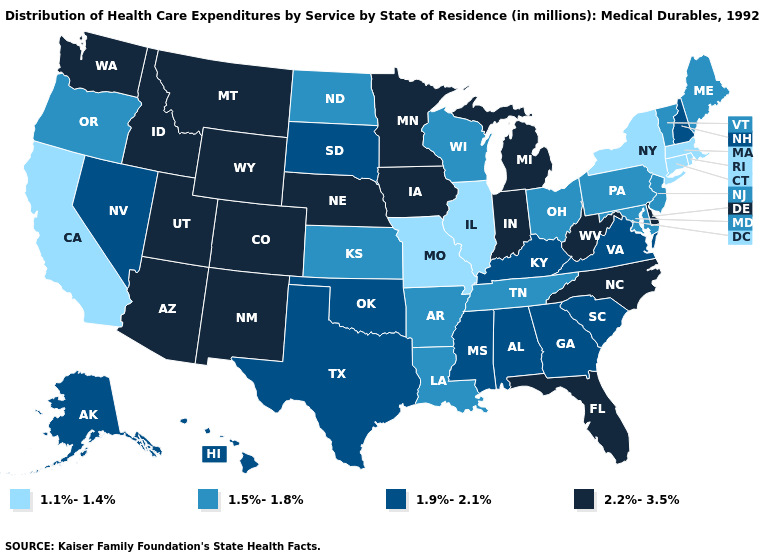Does the first symbol in the legend represent the smallest category?
Give a very brief answer. Yes. What is the lowest value in states that border South Carolina?
Be succinct. 1.9%-2.1%. Does Illinois have the lowest value in the USA?
Give a very brief answer. Yes. Name the states that have a value in the range 2.2%-3.5%?
Concise answer only. Arizona, Colorado, Delaware, Florida, Idaho, Indiana, Iowa, Michigan, Minnesota, Montana, Nebraska, New Mexico, North Carolina, Utah, Washington, West Virginia, Wyoming. What is the value of California?
Concise answer only. 1.1%-1.4%. Name the states that have a value in the range 1.5%-1.8%?
Write a very short answer. Arkansas, Kansas, Louisiana, Maine, Maryland, New Jersey, North Dakota, Ohio, Oregon, Pennsylvania, Tennessee, Vermont, Wisconsin. What is the value of Washington?
Short answer required. 2.2%-3.5%. What is the value of Arizona?
Keep it brief. 2.2%-3.5%. Name the states that have a value in the range 1.5%-1.8%?
Keep it brief. Arkansas, Kansas, Louisiana, Maine, Maryland, New Jersey, North Dakota, Ohio, Oregon, Pennsylvania, Tennessee, Vermont, Wisconsin. Is the legend a continuous bar?
Give a very brief answer. No. Does New Jersey have the same value as New York?
Give a very brief answer. No. Which states have the lowest value in the South?
Quick response, please. Arkansas, Louisiana, Maryland, Tennessee. Name the states that have a value in the range 2.2%-3.5%?
Concise answer only. Arizona, Colorado, Delaware, Florida, Idaho, Indiana, Iowa, Michigan, Minnesota, Montana, Nebraska, New Mexico, North Carolina, Utah, Washington, West Virginia, Wyoming. 